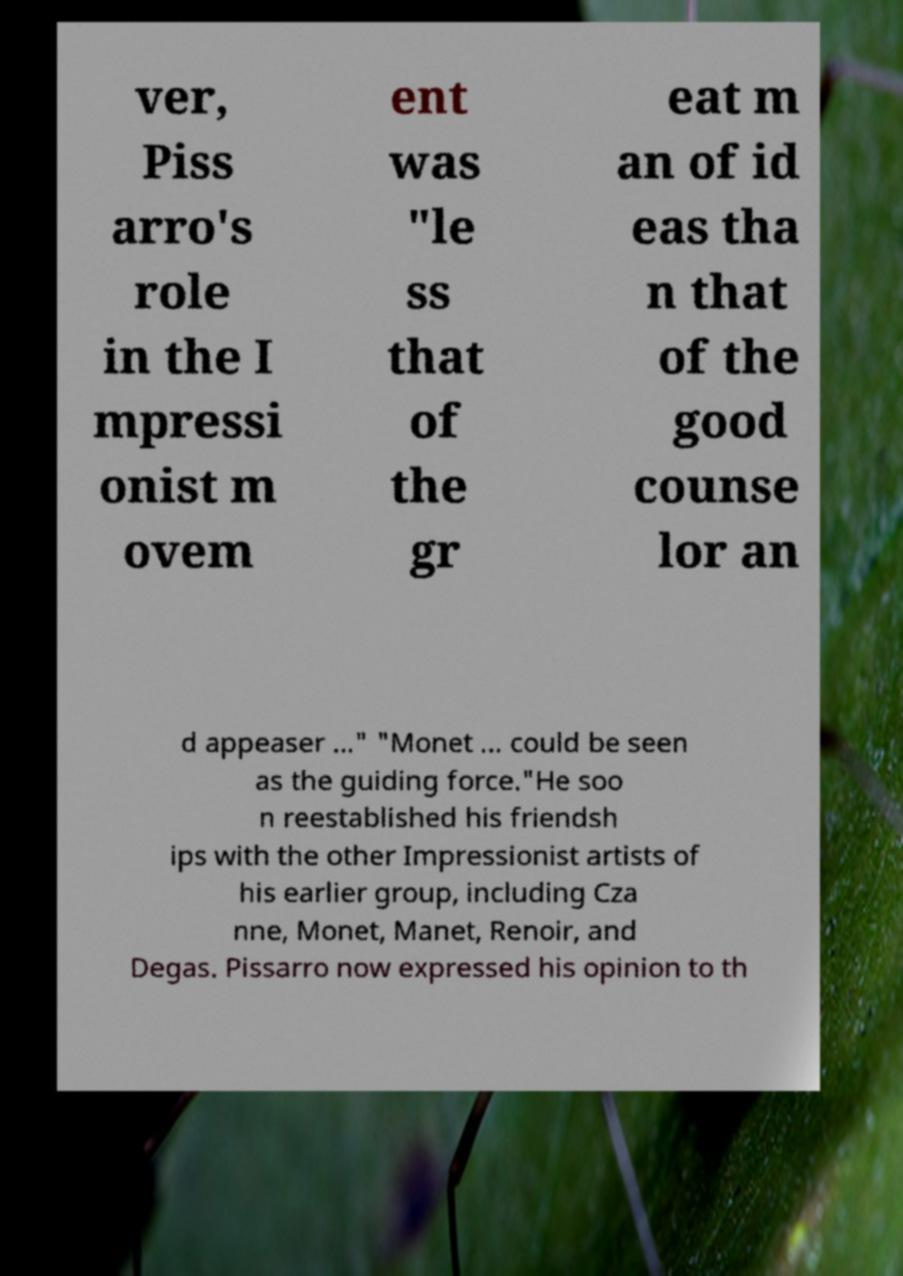Please identify and transcribe the text found in this image. ver, Piss arro's role in the I mpressi onist m ovem ent was "le ss that of the gr eat m an of id eas tha n that of the good counse lor an d appeaser ..." "Monet ... could be seen as the guiding force."He soo n reestablished his friendsh ips with the other Impressionist artists of his earlier group, including Cza nne, Monet, Manet, Renoir, and Degas. Pissarro now expressed his opinion to th 